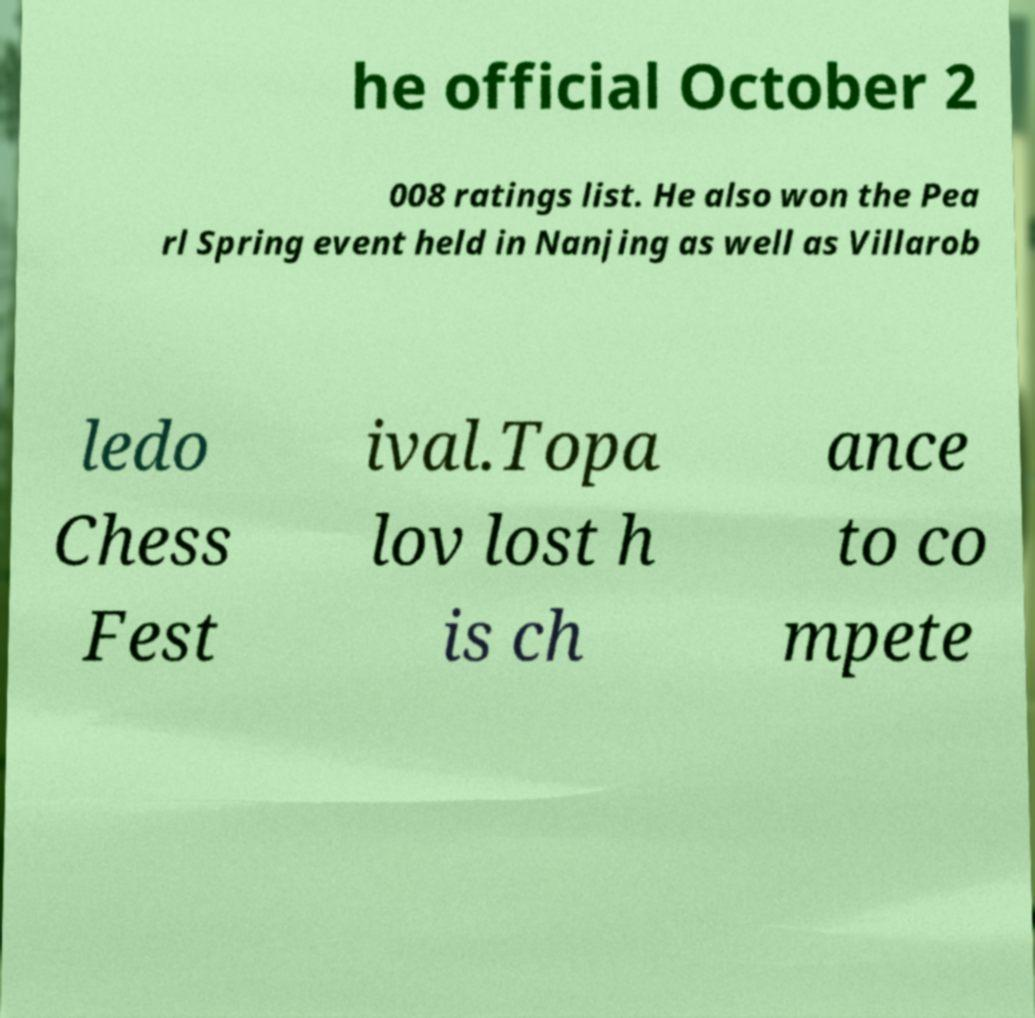Please identify and transcribe the text found in this image. he official October 2 008 ratings list. He also won the Pea rl Spring event held in Nanjing as well as Villarob ledo Chess Fest ival.Topa lov lost h is ch ance to co mpete 